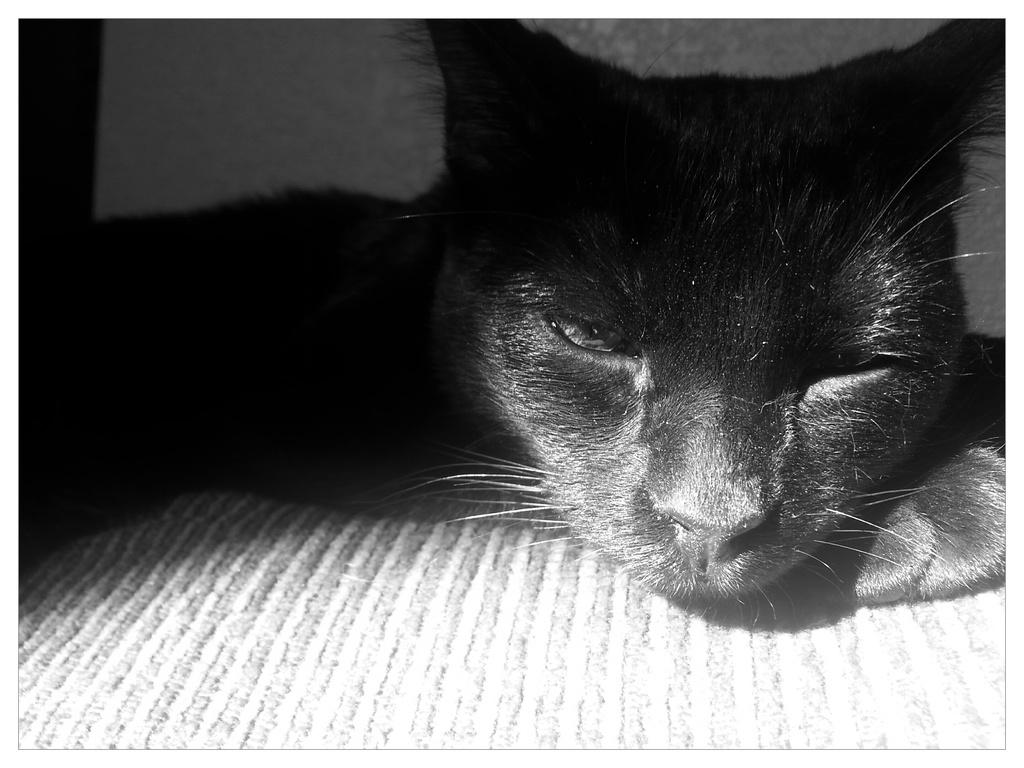What is the main subject in the center of the image? There is a cat lying in the center of the image. What is located at the bottom of the image? There is a cloth at the bottom of the image. How many geese are standing on the cat's tail in the image? There are no geese present in the image, and therefore no geese are standing on the cat's tail. 